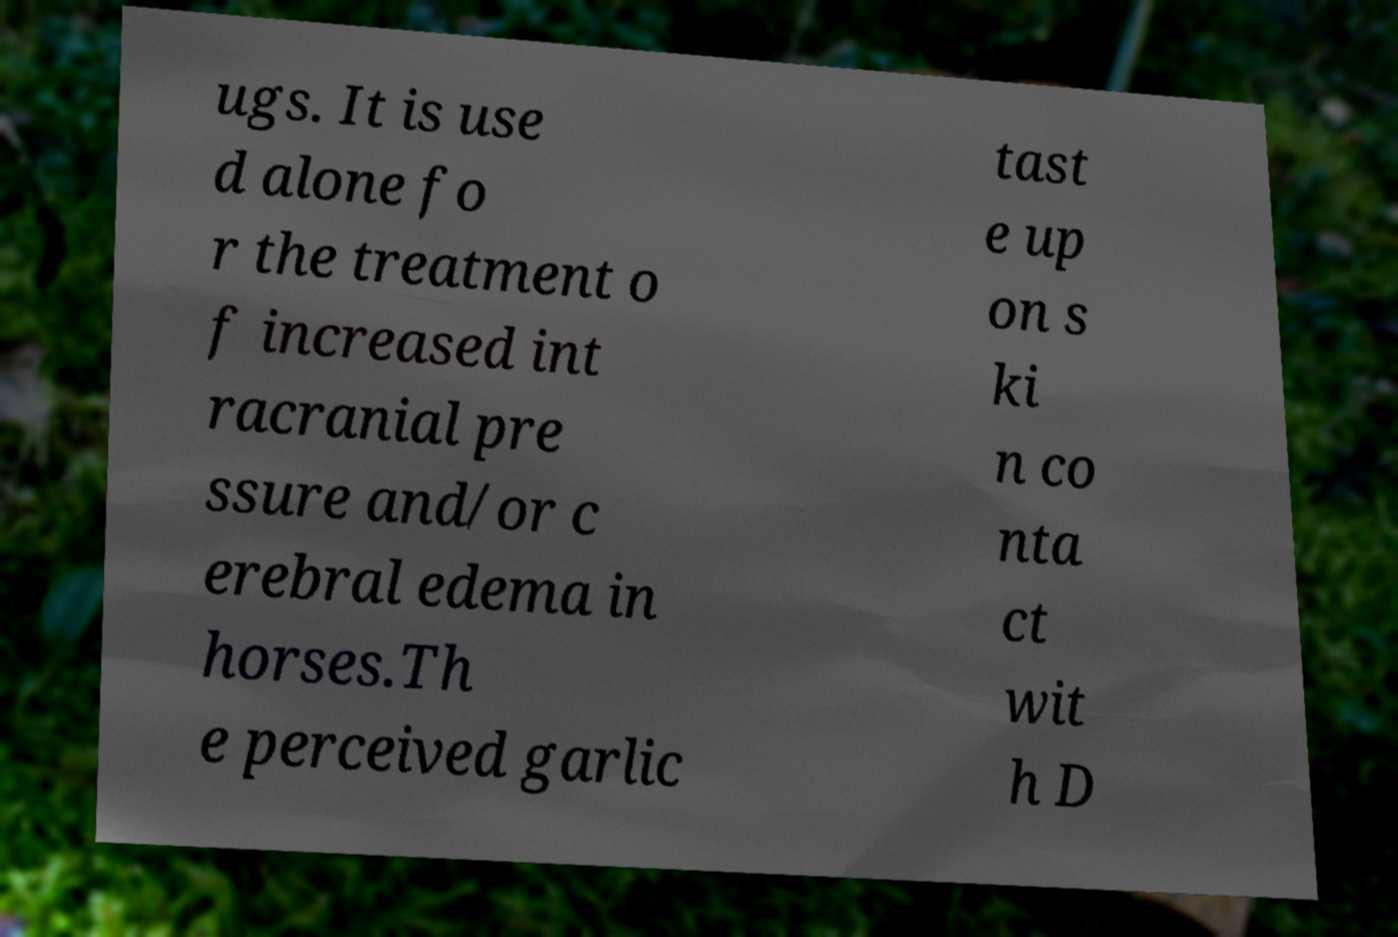For documentation purposes, I need the text within this image transcribed. Could you provide that? ugs. It is use d alone fo r the treatment o f increased int racranial pre ssure and/or c erebral edema in horses.Th e perceived garlic tast e up on s ki n co nta ct wit h D 